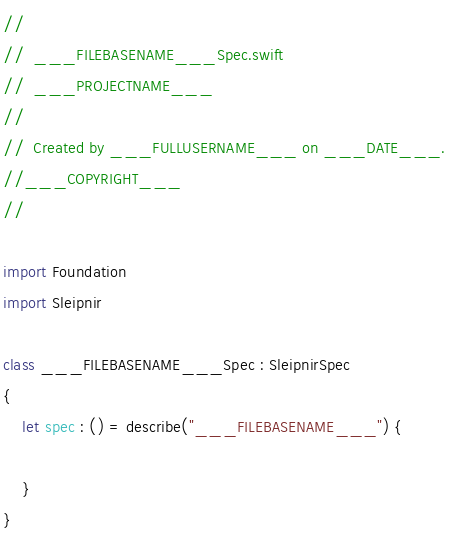Convert code to text. <code><loc_0><loc_0><loc_500><loc_500><_Swift_>//
//  ___FILEBASENAME___Spec.swift
//  ___PROJECTNAME___
//
//  Created by ___FULLUSERNAME___ on ___DATE___.
//___COPYRIGHT___
//

import Foundation
import Sleipnir

class ___FILEBASENAME___Spec : SleipnirSpec 
{
    let spec : () = describe("___FILEBASENAME___") {

    }
}

</code> 